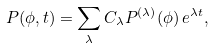<formula> <loc_0><loc_0><loc_500><loc_500>P ( \phi , t ) = \sum _ { \lambda } C _ { \lambda } P ^ { ( \lambda ) } ( \phi ) \, e ^ { \lambda t } ,</formula> 